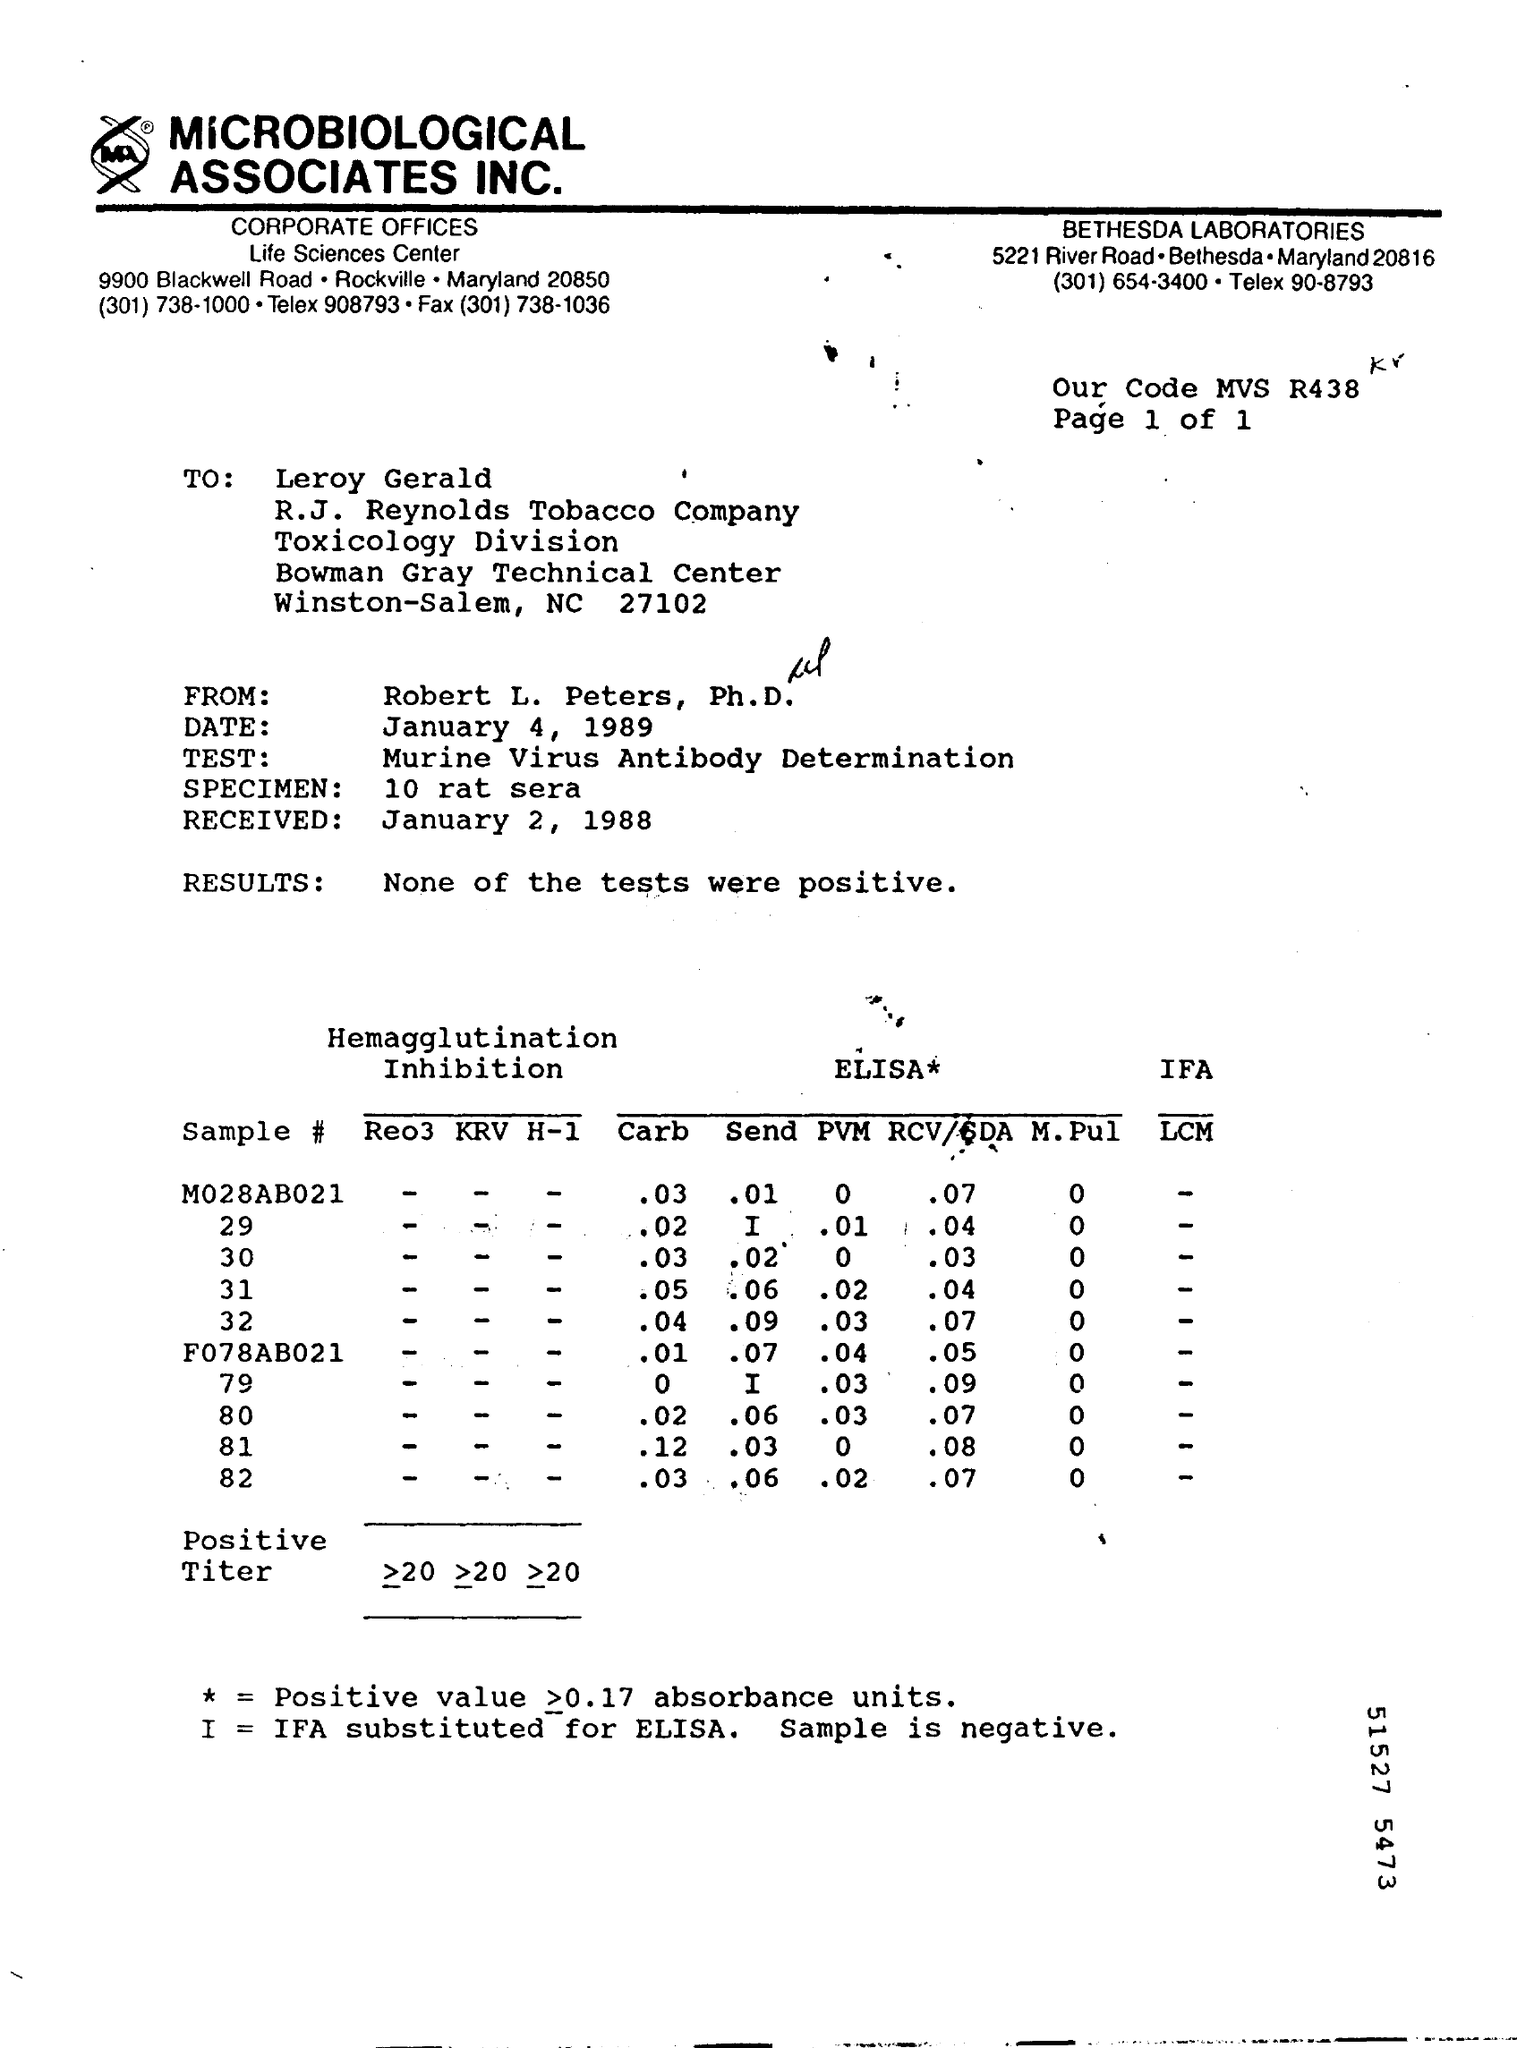Indicate a few pertinent items in this graphic. The sender of this letter is Robert L. Peters, Ph.D. None of the tests conducted were positive. The letter contains a test known as Murine Virus Antibody Determination. The date received in the letter is January 2, 1988. 